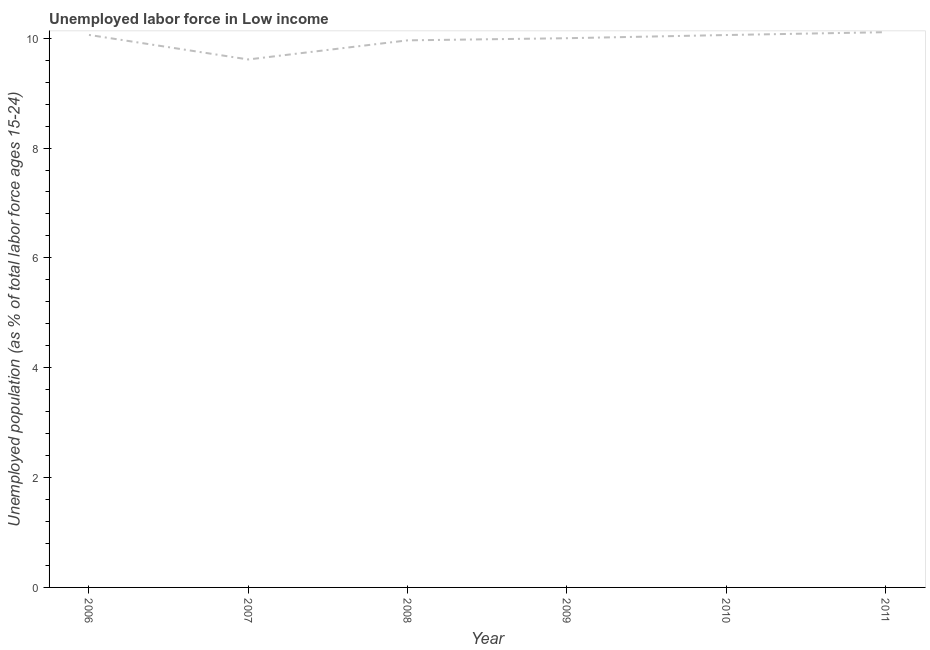What is the total unemployed youth population in 2011?
Make the answer very short. 10.11. Across all years, what is the maximum total unemployed youth population?
Make the answer very short. 10.11. Across all years, what is the minimum total unemployed youth population?
Give a very brief answer. 9.61. What is the sum of the total unemployed youth population?
Keep it short and to the point. 59.8. What is the difference between the total unemployed youth population in 2010 and 2011?
Your answer should be compact. -0.05. What is the average total unemployed youth population per year?
Provide a succinct answer. 9.97. What is the median total unemployed youth population?
Your answer should be compact. 10.03. Do a majority of the years between 2009 and 2011 (inclusive) have total unemployed youth population greater than 5.2 %?
Offer a very short reply. Yes. What is the ratio of the total unemployed youth population in 2007 to that in 2011?
Your response must be concise. 0.95. Is the difference between the total unemployed youth population in 2008 and 2009 greater than the difference between any two years?
Ensure brevity in your answer.  No. What is the difference between the highest and the second highest total unemployed youth population?
Make the answer very short. 0.05. Is the sum of the total unemployed youth population in 2008 and 2011 greater than the maximum total unemployed youth population across all years?
Your response must be concise. Yes. What is the difference between the highest and the lowest total unemployed youth population?
Your answer should be compact. 0.5. In how many years, is the total unemployed youth population greater than the average total unemployed youth population taken over all years?
Provide a succinct answer. 4. Does the total unemployed youth population monotonically increase over the years?
Your answer should be very brief. No. How many lines are there?
Your response must be concise. 1. What is the difference between two consecutive major ticks on the Y-axis?
Give a very brief answer. 2. Are the values on the major ticks of Y-axis written in scientific E-notation?
Give a very brief answer. No. What is the title of the graph?
Give a very brief answer. Unemployed labor force in Low income. What is the label or title of the X-axis?
Your answer should be very brief. Year. What is the label or title of the Y-axis?
Offer a terse response. Unemployed population (as % of total labor force ages 15-24). What is the Unemployed population (as % of total labor force ages 15-24) in 2006?
Ensure brevity in your answer.  10.06. What is the Unemployed population (as % of total labor force ages 15-24) of 2007?
Give a very brief answer. 9.61. What is the Unemployed population (as % of total labor force ages 15-24) of 2008?
Your response must be concise. 9.96. What is the Unemployed population (as % of total labor force ages 15-24) of 2009?
Provide a succinct answer. 10. What is the Unemployed population (as % of total labor force ages 15-24) of 2010?
Keep it short and to the point. 10.06. What is the Unemployed population (as % of total labor force ages 15-24) of 2011?
Give a very brief answer. 10.11. What is the difference between the Unemployed population (as % of total labor force ages 15-24) in 2006 and 2007?
Your response must be concise. 0.45. What is the difference between the Unemployed population (as % of total labor force ages 15-24) in 2006 and 2008?
Offer a terse response. 0.1. What is the difference between the Unemployed population (as % of total labor force ages 15-24) in 2006 and 2009?
Your response must be concise. 0.06. What is the difference between the Unemployed population (as % of total labor force ages 15-24) in 2006 and 2010?
Your answer should be very brief. 0. What is the difference between the Unemployed population (as % of total labor force ages 15-24) in 2006 and 2011?
Offer a terse response. -0.05. What is the difference between the Unemployed population (as % of total labor force ages 15-24) in 2007 and 2008?
Offer a terse response. -0.35. What is the difference between the Unemployed population (as % of total labor force ages 15-24) in 2007 and 2009?
Your answer should be very brief. -0.39. What is the difference between the Unemployed population (as % of total labor force ages 15-24) in 2007 and 2010?
Provide a short and direct response. -0.44. What is the difference between the Unemployed population (as % of total labor force ages 15-24) in 2007 and 2011?
Your answer should be very brief. -0.5. What is the difference between the Unemployed population (as % of total labor force ages 15-24) in 2008 and 2009?
Your response must be concise. -0.04. What is the difference between the Unemployed population (as % of total labor force ages 15-24) in 2008 and 2010?
Make the answer very short. -0.1. What is the difference between the Unemployed population (as % of total labor force ages 15-24) in 2008 and 2011?
Offer a terse response. -0.15. What is the difference between the Unemployed population (as % of total labor force ages 15-24) in 2009 and 2010?
Offer a terse response. -0.06. What is the difference between the Unemployed population (as % of total labor force ages 15-24) in 2009 and 2011?
Ensure brevity in your answer.  -0.11. What is the difference between the Unemployed population (as % of total labor force ages 15-24) in 2010 and 2011?
Your answer should be compact. -0.05. What is the ratio of the Unemployed population (as % of total labor force ages 15-24) in 2006 to that in 2007?
Offer a very short reply. 1.05. What is the ratio of the Unemployed population (as % of total labor force ages 15-24) in 2006 to that in 2008?
Give a very brief answer. 1.01. What is the ratio of the Unemployed population (as % of total labor force ages 15-24) in 2006 to that in 2009?
Offer a very short reply. 1.01. What is the ratio of the Unemployed population (as % of total labor force ages 15-24) in 2006 to that in 2010?
Your answer should be compact. 1. What is the ratio of the Unemployed population (as % of total labor force ages 15-24) in 2007 to that in 2008?
Give a very brief answer. 0.96. What is the ratio of the Unemployed population (as % of total labor force ages 15-24) in 2007 to that in 2009?
Provide a short and direct response. 0.96. What is the ratio of the Unemployed population (as % of total labor force ages 15-24) in 2007 to that in 2010?
Provide a succinct answer. 0.96. What is the ratio of the Unemployed population (as % of total labor force ages 15-24) in 2007 to that in 2011?
Your answer should be very brief. 0.95. What is the ratio of the Unemployed population (as % of total labor force ages 15-24) in 2008 to that in 2009?
Offer a terse response. 1. What is the ratio of the Unemployed population (as % of total labor force ages 15-24) in 2008 to that in 2010?
Keep it short and to the point. 0.99. What is the ratio of the Unemployed population (as % of total labor force ages 15-24) in 2009 to that in 2010?
Your answer should be compact. 0.99. 